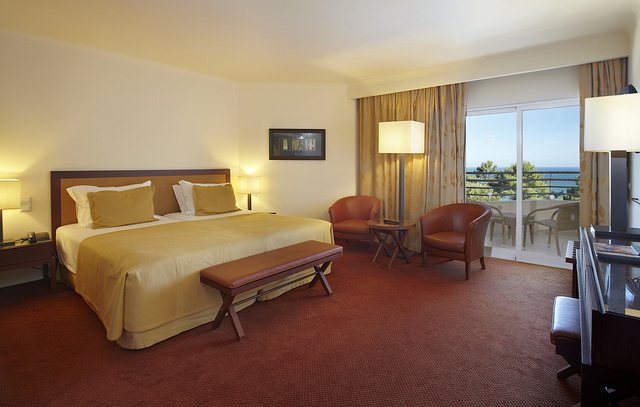What can you tell me about the art in the room? The room features a single piece of artwork above the bed, which appears to be a framed abstract painting. It adds a touch of elegance to the room without overwhelming the space's simple and clean design aesthetic. 